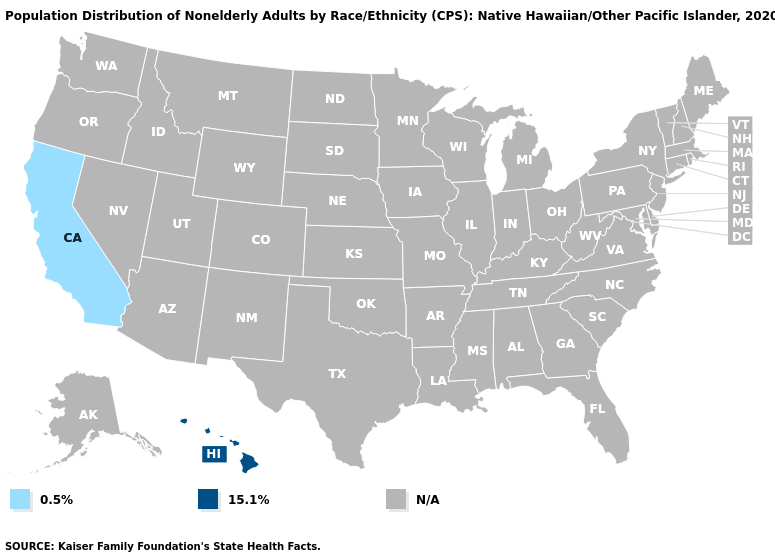Name the states that have a value in the range 0.5%?
Short answer required. California. How many symbols are there in the legend?
Concise answer only. 3. What is the value of Utah?
Concise answer only. N/A. Does the map have missing data?
Quick response, please. Yes. What is the value of Wyoming?
Concise answer only. N/A. Name the states that have a value in the range N/A?
Short answer required. Alabama, Alaska, Arizona, Arkansas, Colorado, Connecticut, Delaware, Florida, Georgia, Idaho, Illinois, Indiana, Iowa, Kansas, Kentucky, Louisiana, Maine, Maryland, Massachusetts, Michigan, Minnesota, Mississippi, Missouri, Montana, Nebraska, Nevada, New Hampshire, New Jersey, New Mexico, New York, North Carolina, North Dakota, Ohio, Oklahoma, Oregon, Pennsylvania, Rhode Island, South Carolina, South Dakota, Tennessee, Texas, Utah, Vermont, Virginia, Washington, West Virginia, Wisconsin, Wyoming. What is the lowest value in the USA?
Write a very short answer. 0.5%. What is the lowest value in the USA?
Answer briefly. 0.5%. Name the states that have a value in the range 0.5%?
Quick response, please. California. Does California have the lowest value in the USA?
Concise answer only. Yes. Name the states that have a value in the range 0.5%?
Answer briefly. California. What is the highest value in the USA?
Concise answer only. 15.1%. 